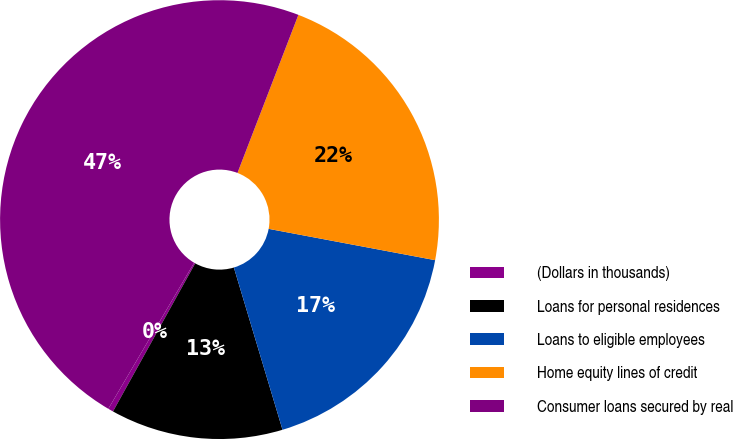<chart> <loc_0><loc_0><loc_500><loc_500><pie_chart><fcel>(Dollars in thousands)<fcel>Loans for personal residences<fcel>Loans to eligible employees<fcel>Home equity lines of credit<fcel>Consumer loans secured by real<nl><fcel>0.39%<fcel>12.7%<fcel>17.4%<fcel>22.1%<fcel>47.39%<nl></chart> 